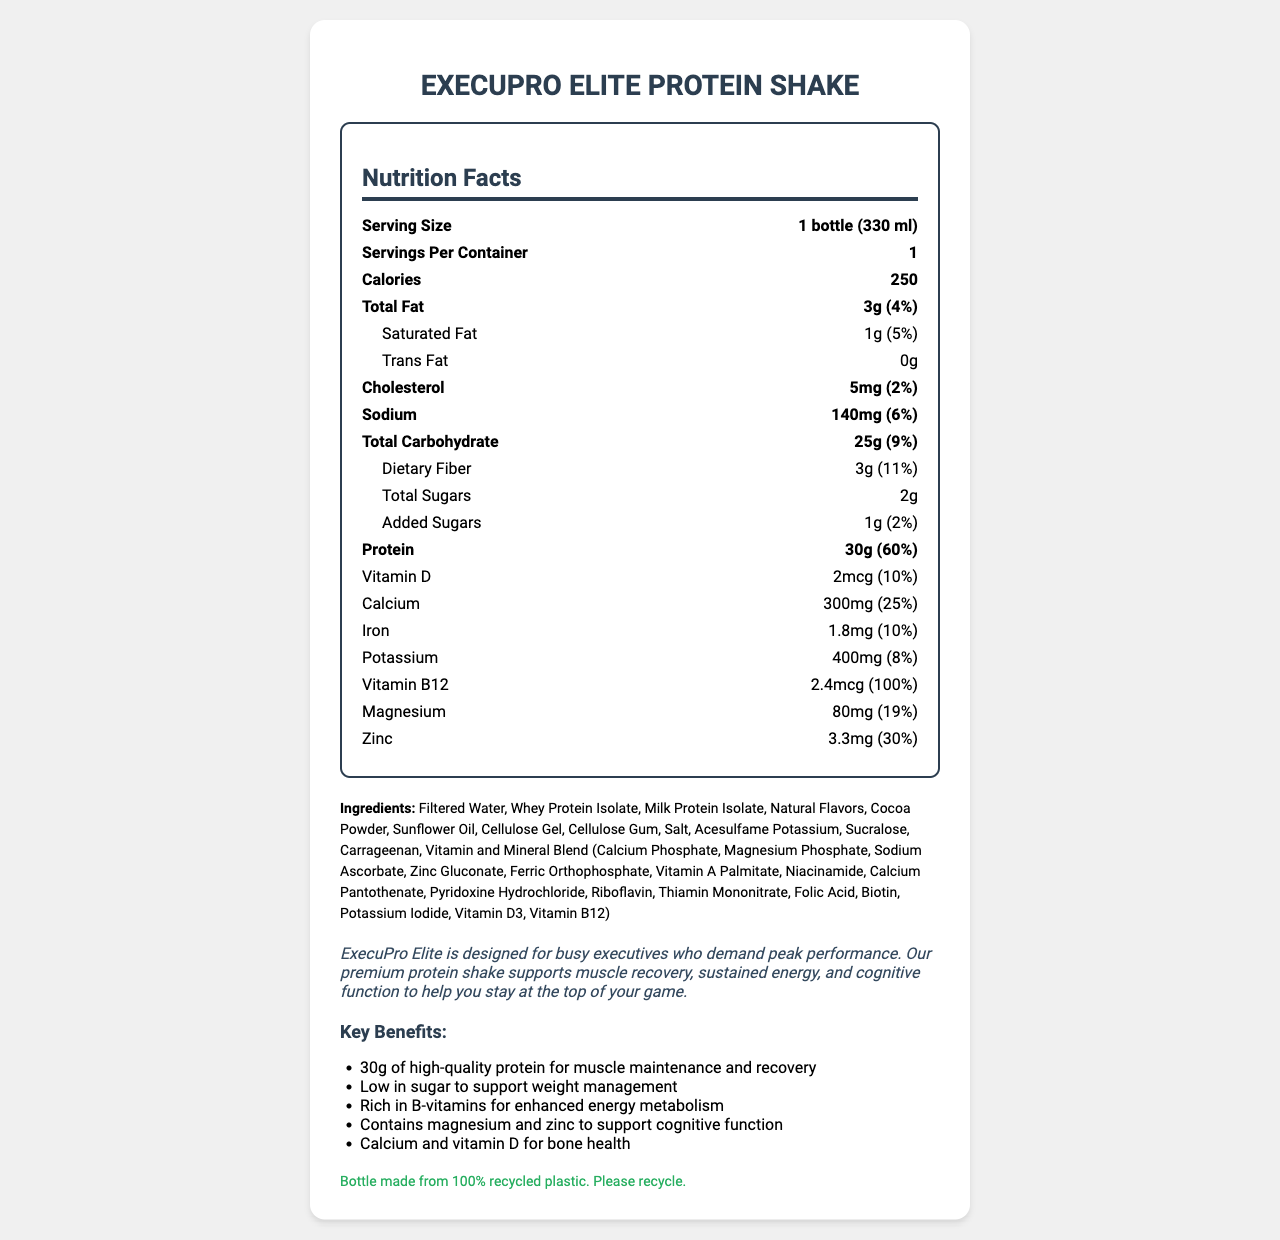what is the serving size for the ExecuPro Elite Protein Shake? The serving size is stated as "1 bottle (330 ml)" near the top of the nutrition facts section.
Answer: 1 bottle (330 ml) How many calories are in one serving of the protein shake? The document mentions "Calories: 250" in the nutrition facts section.
Answer: 250 What is the daily value percentage of protein in one bottle? The nutrition facts indicate that the protein content is 30g, which represents 60% of the daily value.
Answer: 60% What allergen is mentioned in the allergen information? The allergen information states "Contains milk."
Answer: Milk How should the product be stored after opening? The storage instructions clearly mention this detail.
Answer: Keep refrigerated. Consume within 3 days after opening. What is the amount of dietary fiber in the protein shake? The nutrition facts specify "Dietary Fiber: 3g."
Answer: 3g How many grams of total carbohydrates does the protein shake contain? The total carbohydrate amount is listed as 25g in the nutrition facts.
Answer: 25g What is the iron content in the shake and its daily value percentage? The nutrition facts indicate "Iron: 1.8mg (10%)".
Answer: 1.8 mg (10%) What ingredients are listed in the product? The ingredients are listed in a comma-separated format in the document under the section "Ingredients".
Answer: Filtered Water, Whey Protein Isolate, Milk Protein Isolate, Natural Flavors, Cocoa Powder, Sunflower Oil, Cellulose Gel, Cellulose Gum, Salt, Acesulfame Potassium, Sucralose, Carrageenan, Vitamin and Mineral Blend Which vitamin has the highest daily value percentage in the product? A. Vitamin D B. Calcium C. Vitamin B12 D. Magnesium The document states that Vitamin B12 has a 100% daily value, which is the highest among the vitamins and minerals listed.
Answer: C. Vitamin B12 How much calcium is in one serving of the protein shake? A. 300 mg (25%) B. 300 mg (15%) C. 150 mg (25%) D. 150 mg (15%) The nutrition facts state "Calcium: 300mg (25%)".
Answer: A. 300 mg (25%) Is there any trans fat in the product? The trans fat amount is listed as 0g in the nutrition facts section.
Answer: No What are the key benefits of the ExecuPro Elite Protein Shake? A section in the document lists the key benefits in a bulleted format under "Key Benefits".
Answer: 30g of high-quality protein for muscle maintenance and recovery, Low in sugar to support weight management, Rich in B-vitamins for enhanced energy metabolism, Contains magnesium and zinc to support cognitive function, Calcium and vitamin D for bone health Can you tell if the product is gluten-free from the information provided? The document does not provide any information about the gluten content in the product.
Answer: Not enough information Summarize the main idea of the ExecuPro Elite Protein Shake document. The document aims to inform the consumer about the nutritional profile, benefits, and storage of the product, emphasizing its formulation for busy professionals.
Answer: The document provides detailed nutrition facts, ingredients, allergens, storage instructions, and key benefits of the ExecuPro Elite Protein Shake, which is designed for busy executives. The shake contains 30g of protein, has low sugar content, is rich in B-vitamins, magnesium, zinc, calcium, and vitamin D, and is packaged in a sustainable bottle. 